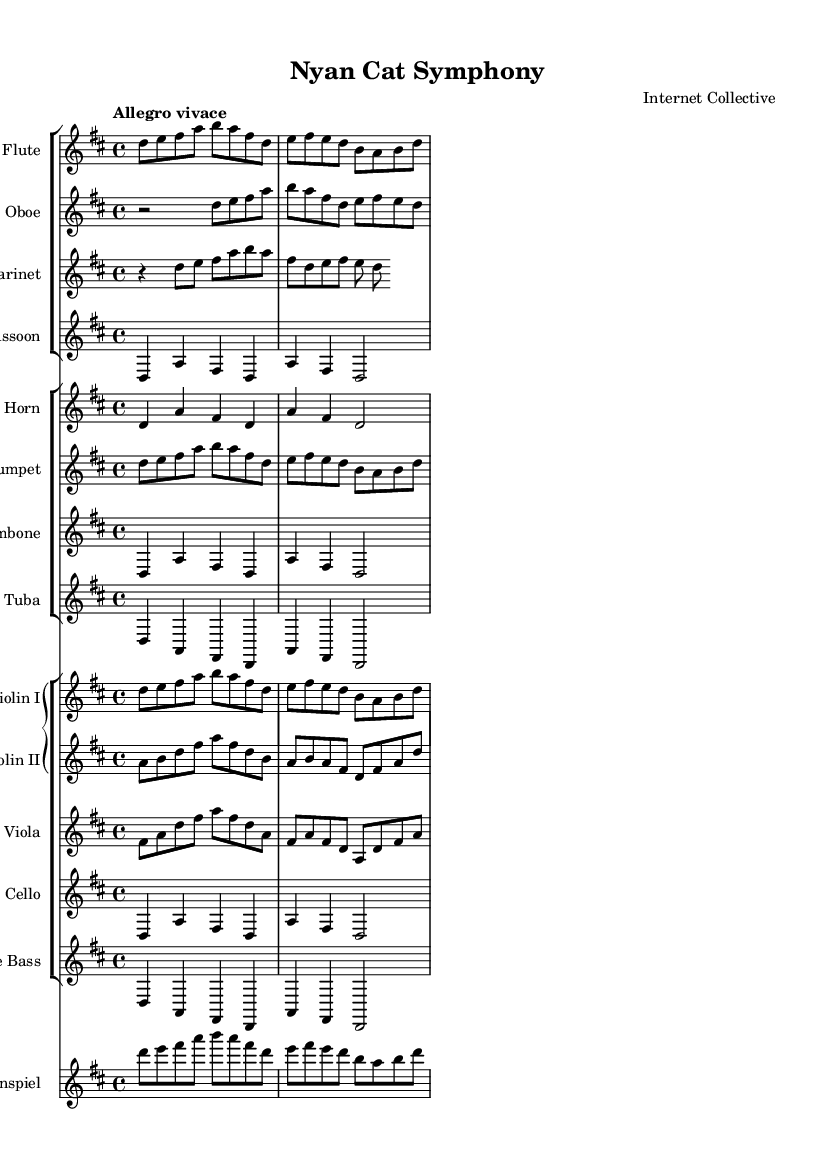What is the key signature of this symphony? The key signature is shown at the beginning of the staff and indicates the notes that are to be played sharp or flat. In this score, there are two sharps, which correspond to F# and C#.
Answer: D major What is the time signature of this piece? The time signature is indicated at the beginning of the score and shows the number of beats in each measure. Here, the time signature is 4/4, meaning there are four beats per measure.
Answer: 4/4 What is the tempo marking for this symphony? The tempo indication is found near the start and tells us how fast or slow the piece should be played. In this case, it is marked as "Allegro vivace," which suggests a lively and brisk tempo.
Answer: Allegro vivace Which instrument plays the melody in the first section? To determine the main melody, we can look for the instrument part that stands out and plays a sequence of notes prominently. Here, the flute part leads with the main melodic line, indicating it plays the melody.
Answer: Flute How many different instrument groups are there in this symphony? The score is organized into multiple staff groups that categorize instruments. There are four groups: Woodwinds, Brass, Strings, and Percussion (glockenspiel). Counting these gives us a total of four distinct instrument groups.
Answer: Four What notes are played by the Violin I in the first measure? The first measure of Violin I contains the notes D, E, F#, A, B, A, F#, D, E, F#. By looking at the first measure, you can directly gather these notes from the notation.
Answer: D, E, F sharp, A, B, A, F sharp, D, E, F sharp 